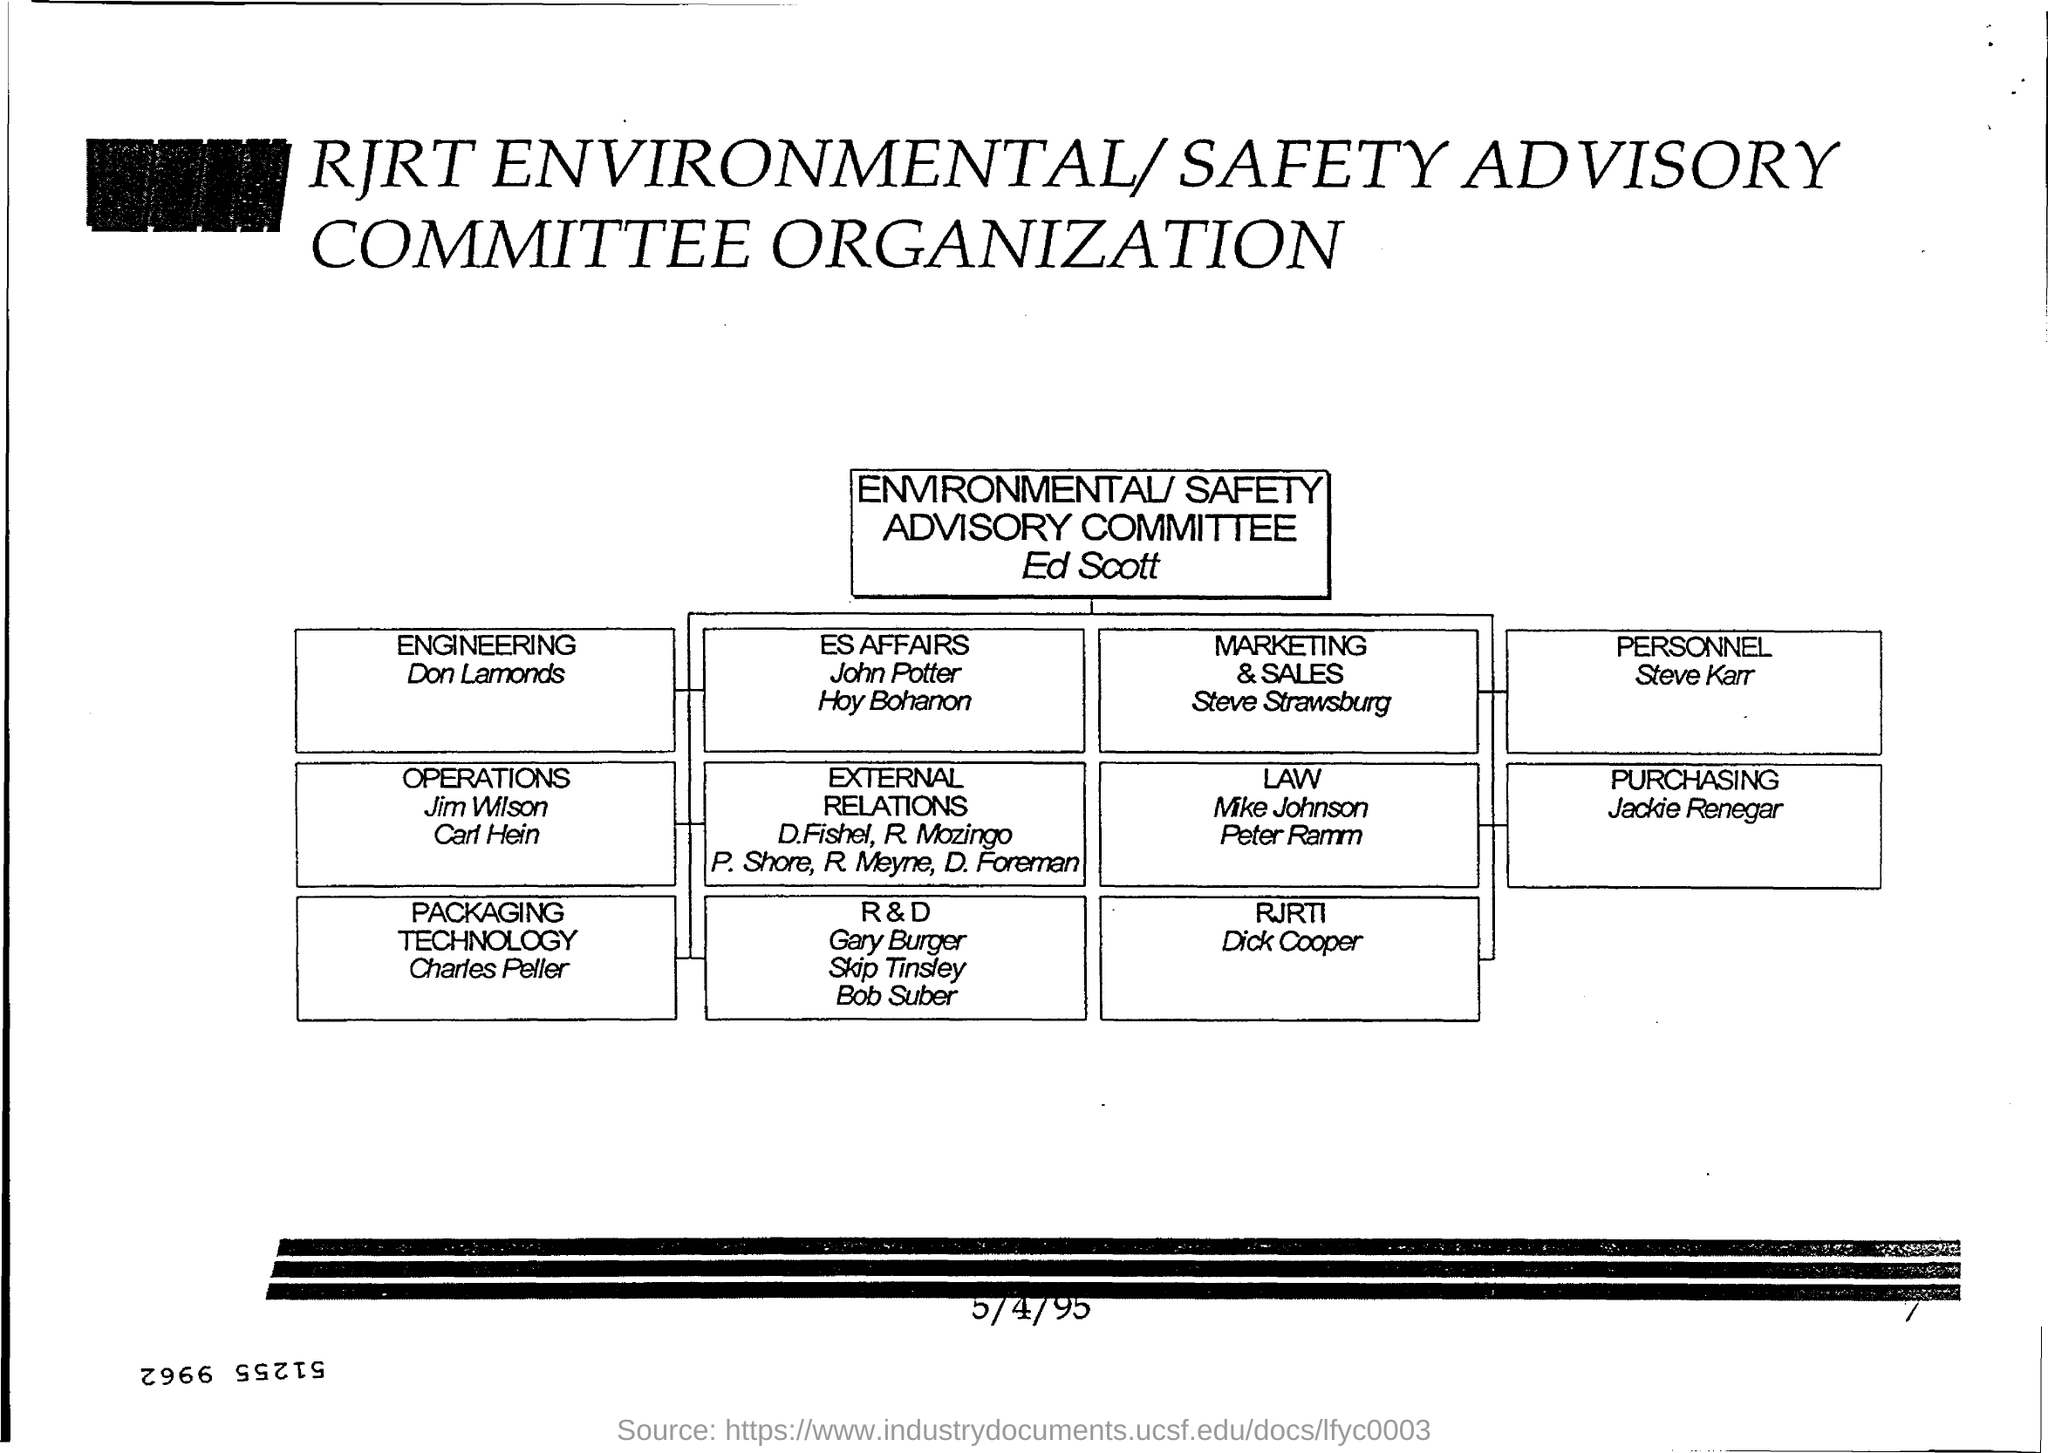What is the date at bottom of the page ?
Offer a terse response. 5/4/95. What is the number at bottom right corner of the page ?
Make the answer very short. 7. Who is the person concerned to "engineering" ?
Your answer should be very brief. Don lamonds. To which department does charles peller belongs?
Make the answer very short. Packaging technology. 